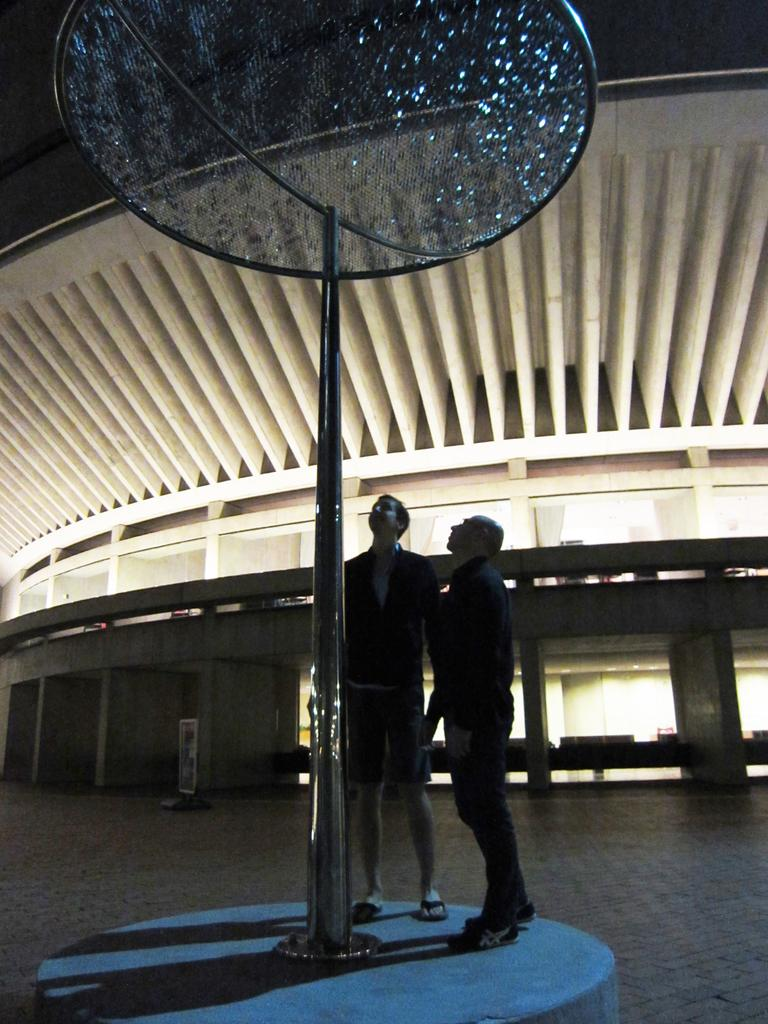How many people are present in the image? There are two persons in the image. What can be seen in the image besides the people? There is a pole in the image. What is visible in the background of the image? There is a building in the background of the image. What type of grass is growing near the pole in the image? There is no grass visible in the image; it features two persons and a pole, with a building in the background. 